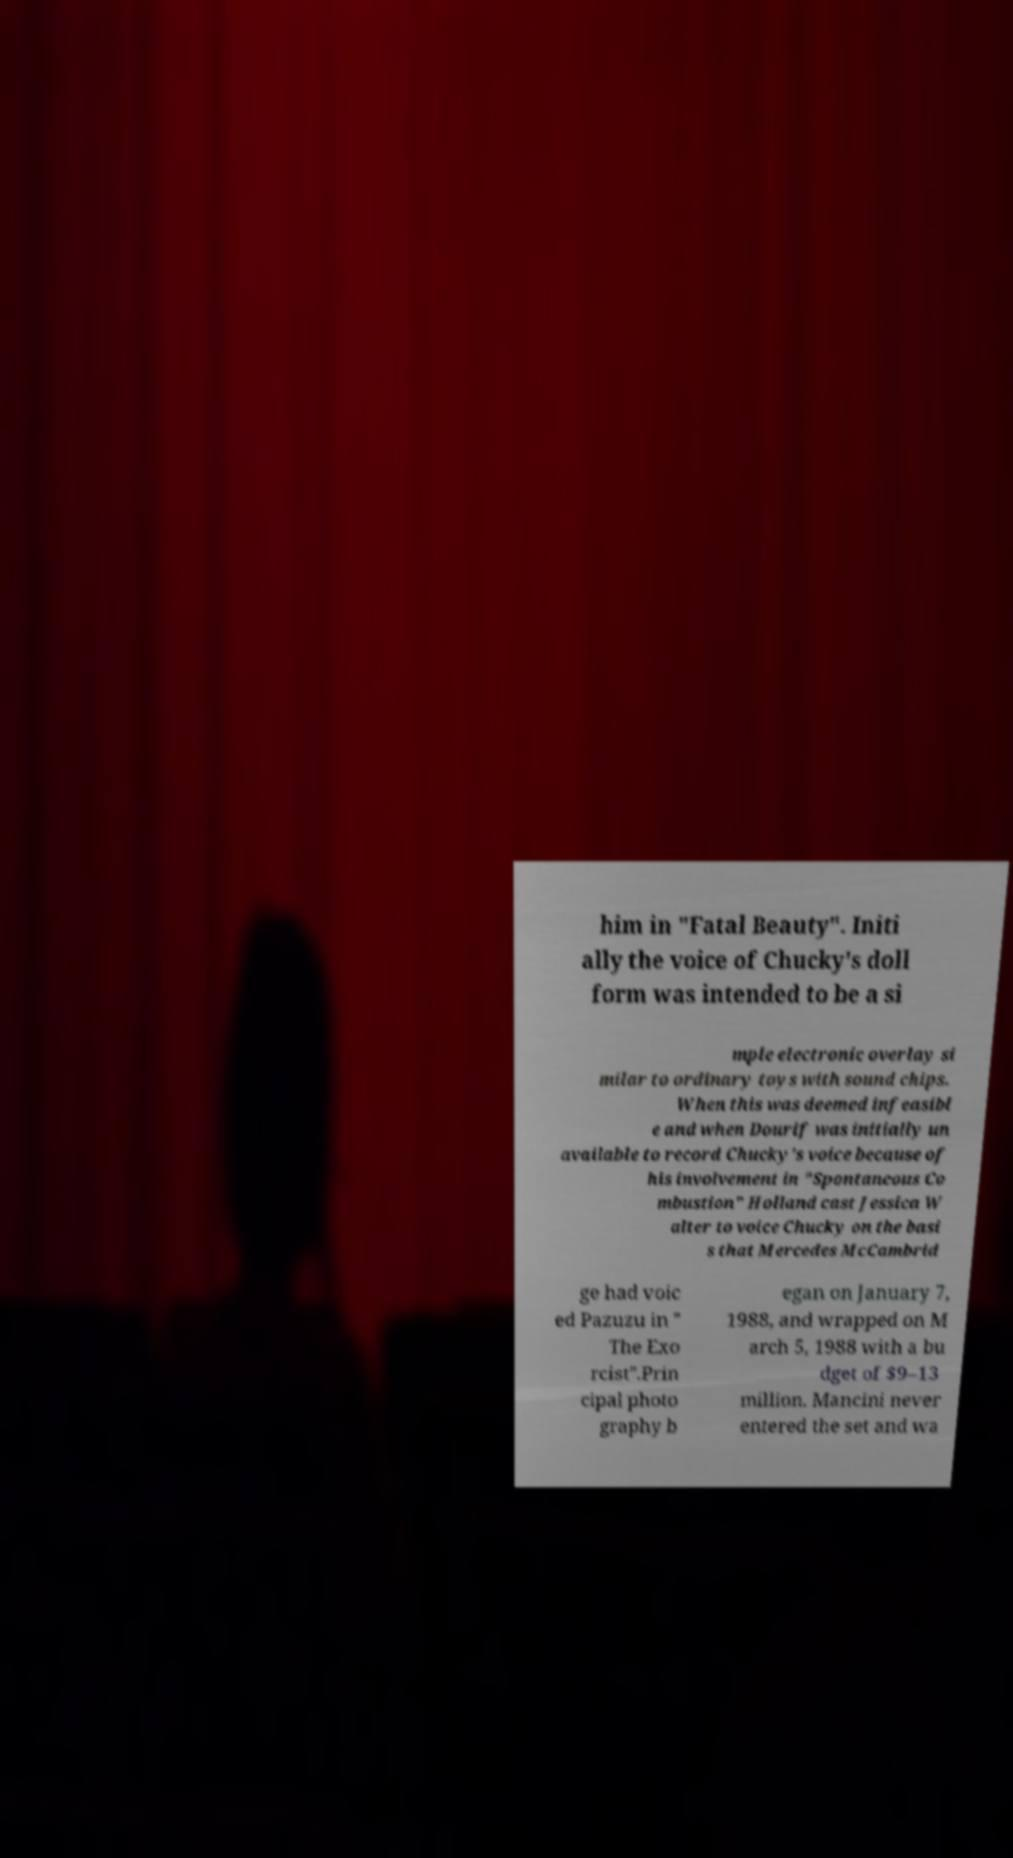I need the written content from this picture converted into text. Can you do that? him in "Fatal Beauty". Initi ally the voice of Chucky's doll form was intended to be a si mple electronic overlay si milar to ordinary toys with sound chips. When this was deemed infeasibl e and when Dourif was initially un available to record Chucky's voice because of his involvement in "Spontaneous Co mbustion" Holland cast Jessica W alter to voice Chucky on the basi s that Mercedes McCambrid ge had voic ed Pazuzu in " The Exo rcist".Prin cipal photo graphy b egan on January 7, 1988, and wrapped on M arch 5, 1988 with a bu dget of $9–13 million. Mancini never entered the set and wa 